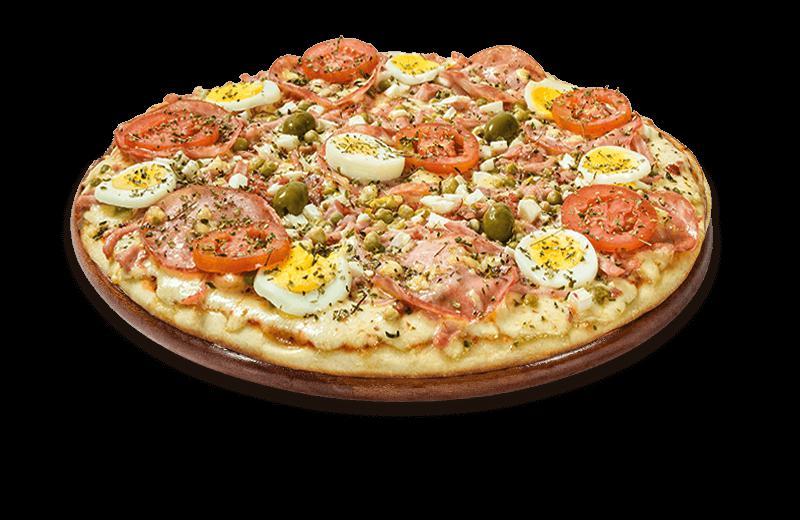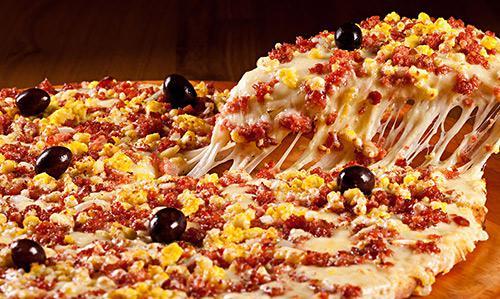The first image is the image on the left, the second image is the image on the right. Assess this claim about the two images: "An image shows a single slice of pizza lifted upward, with cheese stretching all along the side.". Correct or not? Answer yes or no. Yes. 